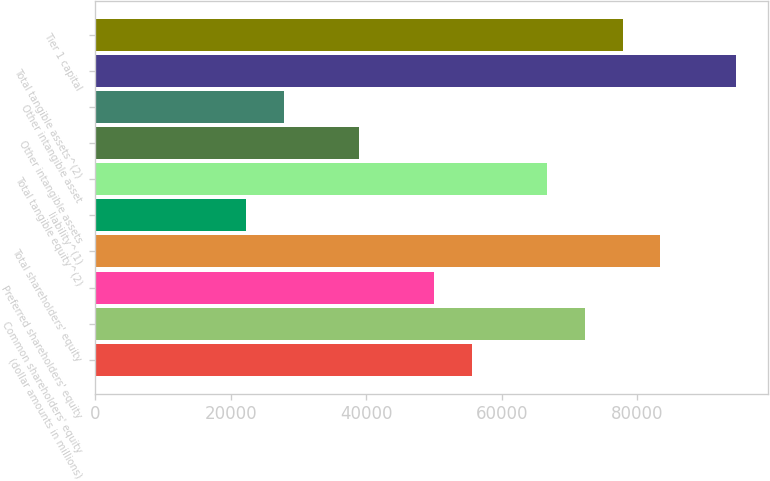<chart> <loc_0><loc_0><loc_500><loc_500><bar_chart><fcel>(dollar amounts in millions)<fcel>Common shareholders' equity<fcel>Preferred shareholders' equity<fcel>Total shareholders' equity<fcel>liability^(1)<fcel>Total tangible equity^(2)<fcel>Other intangible assets<fcel>Other intangible asset<fcel>Total tangible assets^(2)<fcel>Tier 1 capital<nl><fcel>55623<fcel>72307.2<fcel>50061.5<fcel>83430.1<fcel>22254.4<fcel>66745.8<fcel>38938.7<fcel>27815.9<fcel>94552.9<fcel>77868.6<nl></chart> 